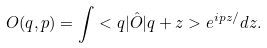Convert formula to latex. <formula><loc_0><loc_0><loc_500><loc_500>O ( q , p ) = \int < q | \hat { O } | q + z > e ^ { i p z / } d z .</formula> 